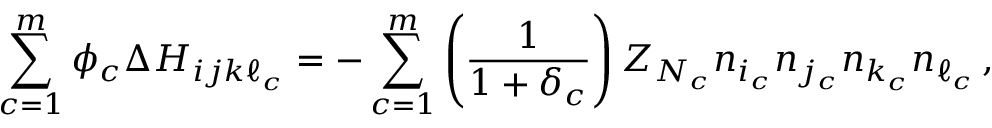Convert formula to latex. <formula><loc_0><loc_0><loc_500><loc_500>\sum _ { c = 1 } ^ { m } \phi _ { c } \Delta H _ { i j k \ell _ { c } } = - \sum _ { c = 1 } ^ { m } \left ( \frac { 1 } { 1 + \delta _ { c } } \right ) Z _ { N _ { c } } n _ { i _ { c } } n _ { j _ { c } } n _ { k _ { c } } n _ { \ell _ { c } } \, ,</formula> 